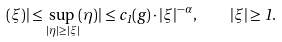Convert formula to latex. <formula><loc_0><loc_0><loc_500><loc_500>( \xi ) | \leq \sup _ { | \eta | \geq | \xi | } ( \eta ) | \leq c _ { 1 } ( g ) \cdot | \xi | ^ { - \alpha } , \quad | \xi | \geq 1 .</formula> 